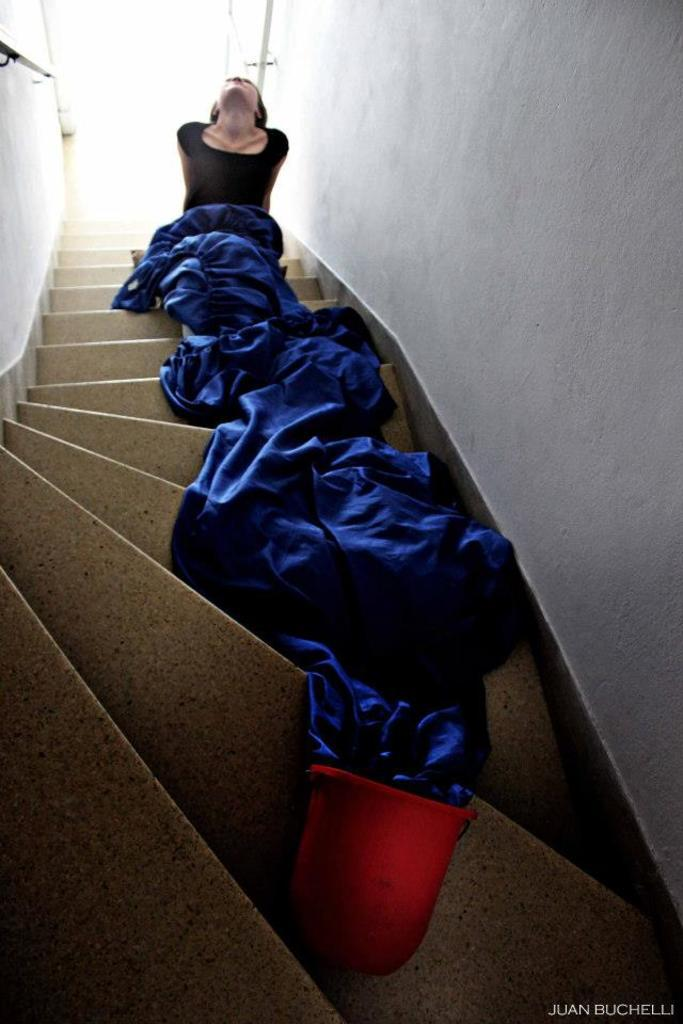What architectural feature is present in the image? There are steps in the image. Who is present in the image? There are women in the image. What type of material is visible in the image? There is cloth visible in the image. What can be seen in the background of the image? There is a wall and rods in the background of the image. Where is the text located in the image? The text is in the bottom right corner of the image. What type of back support is offered by the rods in the image? There is no indication in the image that the rods are providing back support, as they are simply visible in the background. 